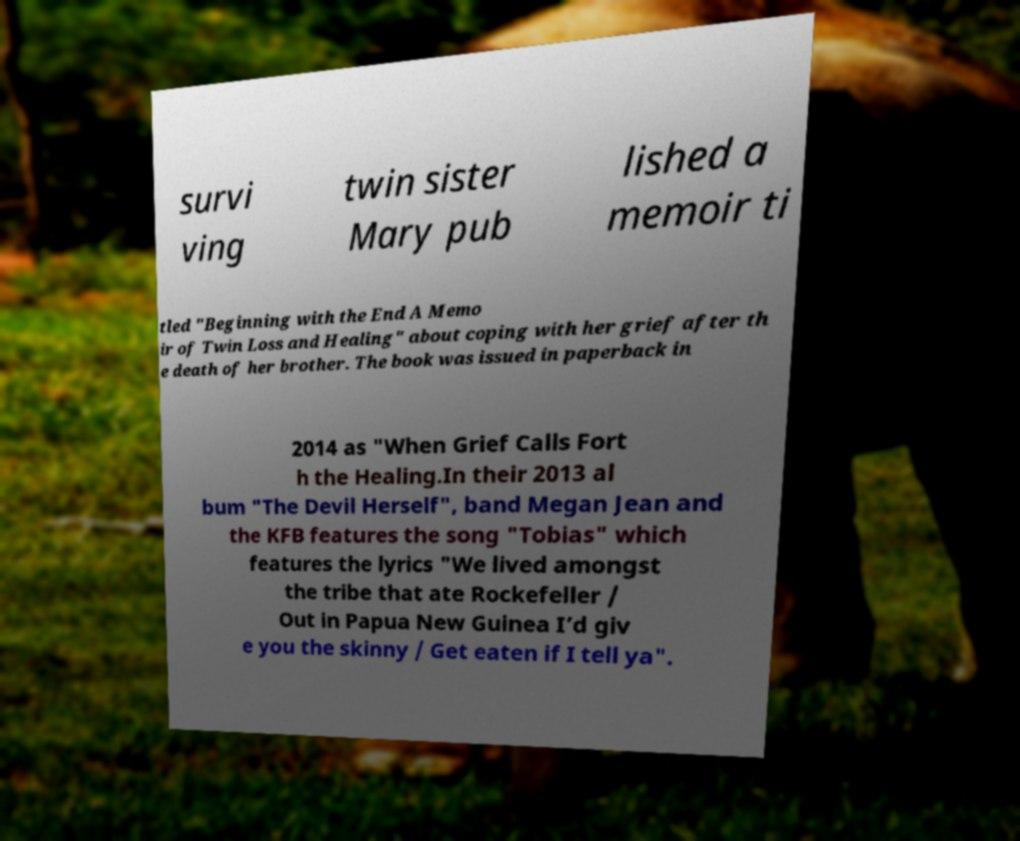What messages or text are displayed in this image? I need them in a readable, typed format. survi ving twin sister Mary pub lished a memoir ti tled "Beginning with the End A Memo ir of Twin Loss and Healing" about coping with her grief after th e death of her brother. The book was issued in paperback in 2014 as "When Grief Calls Fort h the Healing.In their 2013 al bum "The Devil Herself", band Megan Jean and the KFB features the song "Tobias" which features the lyrics "We lived amongst the tribe that ate Rockefeller / Out in Papua New Guinea I’d giv e you the skinny / Get eaten if I tell ya". 